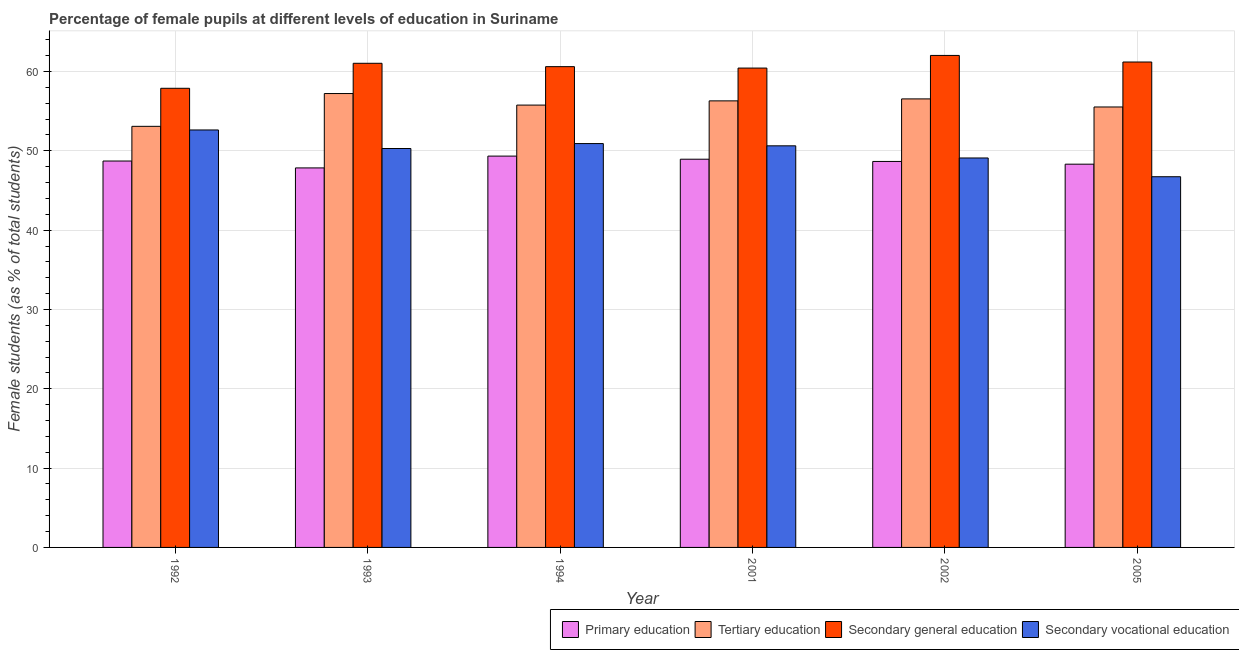Are the number of bars per tick equal to the number of legend labels?
Make the answer very short. Yes. Are the number of bars on each tick of the X-axis equal?
Your response must be concise. Yes. What is the label of the 1st group of bars from the left?
Give a very brief answer. 1992. In how many cases, is the number of bars for a given year not equal to the number of legend labels?
Offer a terse response. 0. What is the percentage of female students in secondary education in 1992?
Make the answer very short. 57.89. Across all years, what is the maximum percentage of female students in primary education?
Your response must be concise. 49.34. Across all years, what is the minimum percentage of female students in primary education?
Make the answer very short. 47.85. In which year was the percentage of female students in secondary vocational education maximum?
Provide a succinct answer. 1992. In which year was the percentage of female students in secondary education minimum?
Provide a succinct answer. 1992. What is the total percentage of female students in secondary vocational education in the graph?
Your answer should be very brief. 300.32. What is the difference between the percentage of female students in secondary vocational education in 1993 and that in 2005?
Provide a short and direct response. 3.56. What is the difference between the percentage of female students in secondary education in 1992 and the percentage of female students in primary education in 2005?
Give a very brief answer. -3.31. What is the average percentage of female students in tertiary education per year?
Your answer should be very brief. 55.75. In the year 2001, what is the difference between the percentage of female students in primary education and percentage of female students in secondary education?
Keep it short and to the point. 0. What is the ratio of the percentage of female students in secondary education in 1992 to that in 2005?
Provide a short and direct response. 0.95. Is the percentage of female students in secondary vocational education in 1993 less than that in 1994?
Your response must be concise. Yes. Is the difference between the percentage of female students in primary education in 1992 and 2002 greater than the difference between the percentage of female students in tertiary education in 1992 and 2002?
Offer a very short reply. No. What is the difference between the highest and the second highest percentage of female students in secondary vocational education?
Make the answer very short. 1.72. What is the difference between the highest and the lowest percentage of female students in primary education?
Ensure brevity in your answer.  1.49. In how many years, is the percentage of female students in tertiary education greater than the average percentage of female students in tertiary education taken over all years?
Ensure brevity in your answer.  4. What does the 3rd bar from the left in 2002 represents?
Your answer should be compact. Secondary general education. What does the 3rd bar from the right in 1993 represents?
Provide a short and direct response. Tertiary education. Is it the case that in every year, the sum of the percentage of female students in primary education and percentage of female students in tertiary education is greater than the percentage of female students in secondary education?
Keep it short and to the point. Yes. How many years are there in the graph?
Offer a very short reply. 6. Does the graph contain any zero values?
Make the answer very short. No. How many legend labels are there?
Your answer should be very brief. 4. What is the title of the graph?
Give a very brief answer. Percentage of female pupils at different levels of education in Suriname. What is the label or title of the Y-axis?
Offer a terse response. Female students (as % of total students). What is the Female students (as % of total students) of Primary education in 1992?
Make the answer very short. 48.72. What is the Female students (as % of total students) in Tertiary education in 1992?
Provide a succinct answer. 53.09. What is the Female students (as % of total students) in Secondary general education in 1992?
Your answer should be compact. 57.89. What is the Female students (as % of total students) of Secondary vocational education in 1992?
Give a very brief answer. 52.63. What is the Female students (as % of total students) in Primary education in 1993?
Keep it short and to the point. 47.85. What is the Female students (as % of total students) of Tertiary education in 1993?
Provide a short and direct response. 57.23. What is the Female students (as % of total students) in Secondary general education in 1993?
Make the answer very short. 61.04. What is the Female students (as % of total students) of Secondary vocational education in 1993?
Provide a succinct answer. 50.3. What is the Female students (as % of total students) in Primary education in 1994?
Make the answer very short. 49.34. What is the Female students (as % of total students) of Tertiary education in 1994?
Ensure brevity in your answer.  55.77. What is the Female students (as % of total students) in Secondary general education in 1994?
Your response must be concise. 60.62. What is the Female students (as % of total students) of Secondary vocational education in 1994?
Your answer should be very brief. 50.92. What is the Female students (as % of total students) in Primary education in 2001?
Your answer should be compact. 48.95. What is the Female students (as % of total students) in Tertiary education in 2001?
Your response must be concise. 56.3. What is the Female students (as % of total students) in Secondary general education in 2001?
Your answer should be very brief. 60.44. What is the Female students (as % of total students) of Secondary vocational education in 2001?
Give a very brief answer. 50.63. What is the Female students (as % of total students) in Primary education in 2002?
Ensure brevity in your answer.  48.67. What is the Female students (as % of total students) in Tertiary education in 2002?
Offer a very short reply. 56.55. What is the Female students (as % of total students) in Secondary general education in 2002?
Your response must be concise. 62.03. What is the Female students (as % of total students) of Secondary vocational education in 2002?
Provide a succinct answer. 49.1. What is the Female students (as % of total students) of Primary education in 2005?
Provide a succinct answer. 48.32. What is the Female students (as % of total students) in Tertiary education in 2005?
Make the answer very short. 55.53. What is the Female students (as % of total students) in Secondary general education in 2005?
Give a very brief answer. 61.2. What is the Female students (as % of total students) of Secondary vocational education in 2005?
Make the answer very short. 46.74. Across all years, what is the maximum Female students (as % of total students) in Primary education?
Your response must be concise. 49.34. Across all years, what is the maximum Female students (as % of total students) of Tertiary education?
Provide a short and direct response. 57.23. Across all years, what is the maximum Female students (as % of total students) of Secondary general education?
Provide a succinct answer. 62.03. Across all years, what is the maximum Female students (as % of total students) in Secondary vocational education?
Make the answer very short. 52.63. Across all years, what is the minimum Female students (as % of total students) in Primary education?
Keep it short and to the point. 47.85. Across all years, what is the minimum Female students (as % of total students) of Tertiary education?
Make the answer very short. 53.09. Across all years, what is the minimum Female students (as % of total students) of Secondary general education?
Your answer should be very brief. 57.89. Across all years, what is the minimum Female students (as % of total students) of Secondary vocational education?
Offer a very short reply. 46.74. What is the total Female students (as % of total students) in Primary education in the graph?
Your answer should be compact. 291.83. What is the total Female students (as % of total students) in Tertiary education in the graph?
Offer a terse response. 334.47. What is the total Female students (as % of total students) in Secondary general education in the graph?
Offer a terse response. 363.21. What is the total Female students (as % of total students) of Secondary vocational education in the graph?
Offer a terse response. 300.32. What is the difference between the Female students (as % of total students) in Primary education in 1992 and that in 1993?
Keep it short and to the point. 0.87. What is the difference between the Female students (as % of total students) of Tertiary education in 1992 and that in 1993?
Make the answer very short. -4.14. What is the difference between the Female students (as % of total students) in Secondary general education in 1992 and that in 1993?
Ensure brevity in your answer.  -3.15. What is the difference between the Female students (as % of total students) of Secondary vocational education in 1992 and that in 1993?
Your response must be concise. 2.34. What is the difference between the Female students (as % of total students) of Primary education in 1992 and that in 1994?
Provide a short and direct response. -0.62. What is the difference between the Female students (as % of total students) in Tertiary education in 1992 and that in 1994?
Your answer should be very brief. -2.68. What is the difference between the Female students (as % of total students) in Secondary general education in 1992 and that in 1994?
Keep it short and to the point. -2.73. What is the difference between the Female students (as % of total students) of Secondary vocational education in 1992 and that in 1994?
Give a very brief answer. 1.72. What is the difference between the Female students (as % of total students) in Primary education in 1992 and that in 2001?
Your answer should be compact. -0.23. What is the difference between the Female students (as % of total students) in Tertiary education in 1992 and that in 2001?
Give a very brief answer. -3.21. What is the difference between the Female students (as % of total students) in Secondary general education in 1992 and that in 2001?
Your response must be concise. -2.55. What is the difference between the Female students (as % of total students) of Secondary vocational education in 1992 and that in 2001?
Provide a short and direct response. 2. What is the difference between the Female students (as % of total students) of Primary education in 1992 and that in 2002?
Provide a short and direct response. 0.05. What is the difference between the Female students (as % of total students) in Tertiary education in 1992 and that in 2002?
Make the answer very short. -3.46. What is the difference between the Female students (as % of total students) in Secondary general education in 1992 and that in 2002?
Keep it short and to the point. -4.14. What is the difference between the Female students (as % of total students) in Secondary vocational education in 1992 and that in 2002?
Ensure brevity in your answer.  3.53. What is the difference between the Female students (as % of total students) of Primary education in 1992 and that in 2005?
Ensure brevity in your answer.  0.4. What is the difference between the Female students (as % of total students) in Tertiary education in 1992 and that in 2005?
Offer a terse response. -2.44. What is the difference between the Female students (as % of total students) of Secondary general education in 1992 and that in 2005?
Offer a very short reply. -3.31. What is the difference between the Female students (as % of total students) of Secondary vocational education in 1992 and that in 2005?
Keep it short and to the point. 5.9. What is the difference between the Female students (as % of total students) in Primary education in 1993 and that in 1994?
Provide a short and direct response. -1.49. What is the difference between the Female students (as % of total students) of Tertiary education in 1993 and that in 1994?
Offer a very short reply. 1.46. What is the difference between the Female students (as % of total students) of Secondary general education in 1993 and that in 1994?
Your response must be concise. 0.42. What is the difference between the Female students (as % of total students) of Secondary vocational education in 1993 and that in 1994?
Your answer should be very brief. -0.62. What is the difference between the Female students (as % of total students) in Primary education in 1993 and that in 2001?
Your answer should be very brief. -1.1. What is the difference between the Female students (as % of total students) in Tertiary education in 1993 and that in 2001?
Keep it short and to the point. 0.92. What is the difference between the Female students (as % of total students) in Secondary general education in 1993 and that in 2001?
Offer a very short reply. 0.6. What is the difference between the Female students (as % of total students) of Secondary vocational education in 1993 and that in 2001?
Provide a short and direct response. -0.34. What is the difference between the Female students (as % of total students) of Primary education in 1993 and that in 2002?
Keep it short and to the point. -0.82. What is the difference between the Female students (as % of total students) in Tertiary education in 1993 and that in 2002?
Make the answer very short. 0.68. What is the difference between the Female students (as % of total students) of Secondary general education in 1993 and that in 2002?
Your answer should be compact. -0.99. What is the difference between the Female students (as % of total students) of Secondary vocational education in 1993 and that in 2002?
Your answer should be very brief. 1.19. What is the difference between the Female students (as % of total students) of Primary education in 1993 and that in 2005?
Offer a terse response. -0.47. What is the difference between the Female students (as % of total students) in Tertiary education in 1993 and that in 2005?
Your response must be concise. 1.69. What is the difference between the Female students (as % of total students) of Secondary general education in 1993 and that in 2005?
Offer a terse response. -0.16. What is the difference between the Female students (as % of total students) of Secondary vocational education in 1993 and that in 2005?
Provide a succinct answer. 3.56. What is the difference between the Female students (as % of total students) of Primary education in 1994 and that in 2001?
Provide a succinct answer. 0.39. What is the difference between the Female students (as % of total students) in Tertiary education in 1994 and that in 2001?
Your answer should be compact. -0.53. What is the difference between the Female students (as % of total students) in Secondary general education in 1994 and that in 2001?
Offer a terse response. 0.18. What is the difference between the Female students (as % of total students) of Secondary vocational education in 1994 and that in 2001?
Give a very brief answer. 0.28. What is the difference between the Female students (as % of total students) of Primary education in 1994 and that in 2002?
Ensure brevity in your answer.  0.67. What is the difference between the Female students (as % of total students) in Tertiary education in 1994 and that in 2002?
Ensure brevity in your answer.  -0.78. What is the difference between the Female students (as % of total students) of Secondary general education in 1994 and that in 2002?
Ensure brevity in your answer.  -1.42. What is the difference between the Female students (as % of total students) of Secondary vocational education in 1994 and that in 2002?
Your response must be concise. 1.82. What is the difference between the Female students (as % of total students) of Primary education in 1994 and that in 2005?
Give a very brief answer. 1.02. What is the difference between the Female students (as % of total students) of Tertiary education in 1994 and that in 2005?
Keep it short and to the point. 0.24. What is the difference between the Female students (as % of total students) of Secondary general education in 1994 and that in 2005?
Provide a short and direct response. -0.58. What is the difference between the Female students (as % of total students) of Secondary vocational education in 1994 and that in 2005?
Ensure brevity in your answer.  4.18. What is the difference between the Female students (as % of total students) in Primary education in 2001 and that in 2002?
Your answer should be compact. 0.28. What is the difference between the Female students (as % of total students) of Tertiary education in 2001 and that in 2002?
Ensure brevity in your answer.  -0.25. What is the difference between the Female students (as % of total students) of Secondary general education in 2001 and that in 2002?
Ensure brevity in your answer.  -1.59. What is the difference between the Female students (as % of total students) of Secondary vocational education in 2001 and that in 2002?
Offer a terse response. 1.53. What is the difference between the Female students (as % of total students) in Primary education in 2001 and that in 2005?
Your answer should be very brief. 0.62. What is the difference between the Female students (as % of total students) of Tertiary education in 2001 and that in 2005?
Your response must be concise. 0.77. What is the difference between the Female students (as % of total students) of Secondary general education in 2001 and that in 2005?
Your answer should be very brief. -0.76. What is the difference between the Female students (as % of total students) of Secondary vocational education in 2001 and that in 2005?
Give a very brief answer. 3.9. What is the difference between the Female students (as % of total students) in Primary education in 2002 and that in 2005?
Offer a terse response. 0.34. What is the difference between the Female students (as % of total students) of Tertiary education in 2002 and that in 2005?
Offer a terse response. 1.02. What is the difference between the Female students (as % of total students) of Secondary general education in 2002 and that in 2005?
Make the answer very short. 0.83. What is the difference between the Female students (as % of total students) in Secondary vocational education in 2002 and that in 2005?
Offer a terse response. 2.37. What is the difference between the Female students (as % of total students) of Primary education in 1992 and the Female students (as % of total students) of Tertiary education in 1993?
Your response must be concise. -8.51. What is the difference between the Female students (as % of total students) in Primary education in 1992 and the Female students (as % of total students) in Secondary general education in 1993?
Offer a terse response. -12.32. What is the difference between the Female students (as % of total students) in Primary education in 1992 and the Female students (as % of total students) in Secondary vocational education in 1993?
Offer a very short reply. -1.58. What is the difference between the Female students (as % of total students) of Tertiary education in 1992 and the Female students (as % of total students) of Secondary general education in 1993?
Provide a succinct answer. -7.95. What is the difference between the Female students (as % of total students) in Tertiary education in 1992 and the Female students (as % of total students) in Secondary vocational education in 1993?
Your answer should be compact. 2.79. What is the difference between the Female students (as % of total students) of Secondary general education in 1992 and the Female students (as % of total students) of Secondary vocational education in 1993?
Provide a short and direct response. 7.59. What is the difference between the Female students (as % of total students) in Primary education in 1992 and the Female students (as % of total students) in Tertiary education in 1994?
Give a very brief answer. -7.05. What is the difference between the Female students (as % of total students) in Primary education in 1992 and the Female students (as % of total students) in Secondary general education in 1994?
Provide a succinct answer. -11.9. What is the difference between the Female students (as % of total students) in Primary education in 1992 and the Female students (as % of total students) in Secondary vocational education in 1994?
Your response must be concise. -2.2. What is the difference between the Female students (as % of total students) in Tertiary education in 1992 and the Female students (as % of total students) in Secondary general education in 1994?
Offer a very short reply. -7.53. What is the difference between the Female students (as % of total students) in Tertiary education in 1992 and the Female students (as % of total students) in Secondary vocational education in 1994?
Make the answer very short. 2.17. What is the difference between the Female students (as % of total students) of Secondary general education in 1992 and the Female students (as % of total students) of Secondary vocational education in 1994?
Offer a terse response. 6.97. What is the difference between the Female students (as % of total students) of Primary education in 1992 and the Female students (as % of total students) of Tertiary education in 2001?
Provide a succinct answer. -7.58. What is the difference between the Female students (as % of total students) in Primary education in 1992 and the Female students (as % of total students) in Secondary general education in 2001?
Your answer should be very brief. -11.72. What is the difference between the Female students (as % of total students) in Primary education in 1992 and the Female students (as % of total students) in Secondary vocational education in 2001?
Give a very brief answer. -1.92. What is the difference between the Female students (as % of total students) of Tertiary education in 1992 and the Female students (as % of total students) of Secondary general education in 2001?
Offer a terse response. -7.35. What is the difference between the Female students (as % of total students) in Tertiary education in 1992 and the Female students (as % of total students) in Secondary vocational education in 2001?
Offer a terse response. 2.46. What is the difference between the Female students (as % of total students) in Secondary general education in 1992 and the Female students (as % of total students) in Secondary vocational education in 2001?
Provide a short and direct response. 7.25. What is the difference between the Female students (as % of total students) of Primary education in 1992 and the Female students (as % of total students) of Tertiary education in 2002?
Your answer should be very brief. -7.83. What is the difference between the Female students (as % of total students) in Primary education in 1992 and the Female students (as % of total students) in Secondary general education in 2002?
Your answer should be compact. -13.31. What is the difference between the Female students (as % of total students) in Primary education in 1992 and the Female students (as % of total students) in Secondary vocational education in 2002?
Your answer should be compact. -0.38. What is the difference between the Female students (as % of total students) of Tertiary education in 1992 and the Female students (as % of total students) of Secondary general education in 2002?
Your answer should be very brief. -8.94. What is the difference between the Female students (as % of total students) in Tertiary education in 1992 and the Female students (as % of total students) in Secondary vocational education in 2002?
Give a very brief answer. 3.99. What is the difference between the Female students (as % of total students) in Secondary general education in 1992 and the Female students (as % of total students) in Secondary vocational education in 2002?
Your response must be concise. 8.79. What is the difference between the Female students (as % of total students) of Primary education in 1992 and the Female students (as % of total students) of Tertiary education in 2005?
Offer a very short reply. -6.82. What is the difference between the Female students (as % of total students) of Primary education in 1992 and the Female students (as % of total students) of Secondary general education in 2005?
Provide a short and direct response. -12.48. What is the difference between the Female students (as % of total students) of Primary education in 1992 and the Female students (as % of total students) of Secondary vocational education in 2005?
Provide a succinct answer. 1.98. What is the difference between the Female students (as % of total students) of Tertiary education in 1992 and the Female students (as % of total students) of Secondary general education in 2005?
Provide a succinct answer. -8.11. What is the difference between the Female students (as % of total students) of Tertiary education in 1992 and the Female students (as % of total students) of Secondary vocational education in 2005?
Your answer should be very brief. 6.35. What is the difference between the Female students (as % of total students) in Secondary general education in 1992 and the Female students (as % of total students) in Secondary vocational education in 2005?
Offer a terse response. 11.15. What is the difference between the Female students (as % of total students) of Primary education in 1993 and the Female students (as % of total students) of Tertiary education in 1994?
Offer a terse response. -7.92. What is the difference between the Female students (as % of total students) in Primary education in 1993 and the Female students (as % of total students) in Secondary general education in 1994?
Ensure brevity in your answer.  -12.77. What is the difference between the Female students (as % of total students) of Primary education in 1993 and the Female students (as % of total students) of Secondary vocational education in 1994?
Provide a succinct answer. -3.07. What is the difference between the Female students (as % of total students) of Tertiary education in 1993 and the Female students (as % of total students) of Secondary general education in 1994?
Your answer should be very brief. -3.39. What is the difference between the Female students (as % of total students) in Tertiary education in 1993 and the Female students (as % of total students) in Secondary vocational education in 1994?
Make the answer very short. 6.31. What is the difference between the Female students (as % of total students) of Secondary general education in 1993 and the Female students (as % of total students) of Secondary vocational education in 1994?
Make the answer very short. 10.12. What is the difference between the Female students (as % of total students) in Primary education in 1993 and the Female students (as % of total students) in Tertiary education in 2001?
Give a very brief answer. -8.45. What is the difference between the Female students (as % of total students) of Primary education in 1993 and the Female students (as % of total students) of Secondary general education in 2001?
Your answer should be very brief. -12.59. What is the difference between the Female students (as % of total students) in Primary education in 1993 and the Female students (as % of total students) in Secondary vocational education in 2001?
Your response must be concise. -2.79. What is the difference between the Female students (as % of total students) in Tertiary education in 1993 and the Female students (as % of total students) in Secondary general education in 2001?
Keep it short and to the point. -3.21. What is the difference between the Female students (as % of total students) of Tertiary education in 1993 and the Female students (as % of total students) of Secondary vocational education in 2001?
Your answer should be very brief. 6.59. What is the difference between the Female students (as % of total students) in Secondary general education in 1993 and the Female students (as % of total students) in Secondary vocational education in 2001?
Provide a succinct answer. 10.41. What is the difference between the Female students (as % of total students) in Primary education in 1993 and the Female students (as % of total students) in Tertiary education in 2002?
Ensure brevity in your answer.  -8.7. What is the difference between the Female students (as % of total students) in Primary education in 1993 and the Female students (as % of total students) in Secondary general education in 2002?
Provide a succinct answer. -14.18. What is the difference between the Female students (as % of total students) of Primary education in 1993 and the Female students (as % of total students) of Secondary vocational education in 2002?
Offer a very short reply. -1.25. What is the difference between the Female students (as % of total students) in Tertiary education in 1993 and the Female students (as % of total students) in Secondary general education in 2002?
Your answer should be very brief. -4.8. What is the difference between the Female students (as % of total students) in Tertiary education in 1993 and the Female students (as % of total students) in Secondary vocational education in 2002?
Your answer should be very brief. 8.12. What is the difference between the Female students (as % of total students) of Secondary general education in 1993 and the Female students (as % of total students) of Secondary vocational education in 2002?
Make the answer very short. 11.94. What is the difference between the Female students (as % of total students) of Primary education in 1993 and the Female students (as % of total students) of Tertiary education in 2005?
Provide a short and direct response. -7.68. What is the difference between the Female students (as % of total students) in Primary education in 1993 and the Female students (as % of total students) in Secondary general education in 2005?
Your response must be concise. -13.35. What is the difference between the Female students (as % of total students) in Primary education in 1993 and the Female students (as % of total students) in Secondary vocational education in 2005?
Provide a short and direct response. 1.11. What is the difference between the Female students (as % of total students) of Tertiary education in 1993 and the Female students (as % of total students) of Secondary general education in 2005?
Provide a short and direct response. -3.97. What is the difference between the Female students (as % of total students) of Tertiary education in 1993 and the Female students (as % of total students) of Secondary vocational education in 2005?
Offer a terse response. 10.49. What is the difference between the Female students (as % of total students) of Secondary general education in 1993 and the Female students (as % of total students) of Secondary vocational education in 2005?
Your answer should be compact. 14.3. What is the difference between the Female students (as % of total students) of Primary education in 1994 and the Female students (as % of total students) of Tertiary education in 2001?
Offer a very short reply. -6.96. What is the difference between the Female students (as % of total students) of Primary education in 1994 and the Female students (as % of total students) of Secondary general education in 2001?
Your answer should be compact. -11.1. What is the difference between the Female students (as % of total students) in Primary education in 1994 and the Female students (as % of total students) in Secondary vocational education in 2001?
Give a very brief answer. -1.3. What is the difference between the Female students (as % of total students) in Tertiary education in 1994 and the Female students (as % of total students) in Secondary general education in 2001?
Your answer should be compact. -4.67. What is the difference between the Female students (as % of total students) in Tertiary education in 1994 and the Female students (as % of total students) in Secondary vocational education in 2001?
Provide a succinct answer. 5.14. What is the difference between the Female students (as % of total students) in Secondary general education in 1994 and the Female students (as % of total students) in Secondary vocational education in 2001?
Offer a very short reply. 9.98. What is the difference between the Female students (as % of total students) in Primary education in 1994 and the Female students (as % of total students) in Tertiary education in 2002?
Your answer should be compact. -7.21. What is the difference between the Female students (as % of total students) in Primary education in 1994 and the Female students (as % of total students) in Secondary general education in 2002?
Offer a very short reply. -12.69. What is the difference between the Female students (as % of total students) of Primary education in 1994 and the Female students (as % of total students) of Secondary vocational education in 2002?
Give a very brief answer. 0.24. What is the difference between the Female students (as % of total students) of Tertiary education in 1994 and the Female students (as % of total students) of Secondary general education in 2002?
Provide a succinct answer. -6.26. What is the difference between the Female students (as % of total students) of Tertiary education in 1994 and the Female students (as % of total students) of Secondary vocational education in 2002?
Provide a short and direct response. 6.67. What is the difference between the Female students (as % of total students) in Secondary general education in 1994 and the Female students (as % of total students) in Secondary vocational education in 2002?
Your answer should be very brief. 11.51. What is the difference between the Female students (as % of total students) of Primary education in 1994 and the Female students (as % of total students) of Tertiary education in 2005?
Offer a terse response. -6.19. What is the difference between the Female students (as % of total students) of Primary education in 1994 and the Female students (as % of total students) of Secondary general education in 2005?
Keep it short and to the point. -11.86. What is the difference between the Female students (as % of total students) in Primary education in 1994 and the Female students (as % of total students) in Secondary vocational education in 2005?
Your response must be concise. 2.6. What is the difference between the Female students (as % of total students) in Tertiary education in 1994 and the Female students (as % of total students) in Secondary general education in 2005?
Provide a succinct answer. -5.43. What is the difference between the Female students (as % of total students) of Tertiary education in 1994 and the Female students (as % of total students) of Secondary vocational education in 2005?
Keep it short and to the point. 9.03. What is the difference between the Female students (as % of total students) in Secondary general education in 1994 and the Female students (as % of total students) in Secondary vocational education in 2005?
Provide a succinct answer. 13.88. What is the difference between the Female students (as % of total students) of Primary education in 2001 and the Female students (as % of total students) of Tertiary education in 2002?
Your answer should be very brief. -7.61. What is the difference between the Female students (as % of total students) in Primary education in 2001 and the Female students (as % of total students) in Secondary general education in 2002?
Make the answer very short. -13.09. What is the difference between the Female students (as % of total students) in Primary education in 2001 and the Female students (as % of total students) in Secondary vocational education in 2002?
Provide a succinct answer. -0.16. What is the difference between the Female students (as % of total students) of Tertiary education in 2001 and the Female students (as % of total students) of Secondary general education in 2002?
Ensure brevity in your answer.  -5.73. What is the difference between the Female students (as % of total students) in Tertiary education in 2001 and the Female students (as % of total students) in Secondary vocational education in 2002?
Offer a terse response. 7.2. What is the difference between the Female students (as % of total students) of Secondary general education in 2001 and the Female students (as % of total students) of Secondary vocational education in 2002?
Your response must be concise. 11.34. What is the difference between the Female students (as % of total students) of Primary education in 2001 and the Female students (as % of total students) of Tertiary education in 2005?
Make the answer very short. -6.59. What is the difference between the Female students (as % of total students) of Primary education in 2001 and the Female students (as % of total students) of Secondary general education in 2005?
Ensure brevity in your answer.  -12.26. What is the difference between the Female students (as % of total students) of Primary education in 2001 and the Female students (as % of total students) of Secondary vocational education in 2005?
Your response must be concise. 2.21. What is the difference between the Female students (as % of total students) in Tertiary education in 2001 and the Female students (as % of total students) in Secondary general education in 2005?
Make the answer very short. -4.9. What is the difference between the Female students (as % of total students) in Tertiary education in 2001 and the Female students (as % of total students) in Secondary vocational education in 2005?
Offer a very short reply. 9.56. What is the difference between the Female students (as % of total students) in Secondary general education in 2001 and the Female students (as % of total students) in Secondary vocational education in 2005?
Provide a short and direct response. 13.7. What is the difference between the Female students (as % of total students) in Primary education in 2002 and the Female students (as % of total students) in Tertiary education in 2005?
Keep it short and to the point. -6.87. What is the difference between the Female students (as % of total students) in Primary education in 2002 and the Female students (as % of total students) in Secondary general education in 2005?
Make the answer very short. -12.54. What is the difference between the Female students (as % of total students) of Primary education in 2002 and the Female students (as % of total students) of Secondary vocational education in 2005?
Make the answer very short. 1.93. What is the difference between the Female students (as % of total students) of Tertiary education in 2002 and the Female students (as % of total students) of Secondary general education in 2005?
Your answer should be compact. -4.65. What is the difference between the Female students (as % of total students) of Tertiary education in 2002 and the Female students (as % of total students) of Secondary vocational education in 2005?
Your response must be concise. 9.81. What is the difference between the Female students (as % of total students) in Secondary general education in 2002 and the Female students (as % of total students) in Secondary vocational education in 2005?
Offer a terse response. 15.29. What is the average Female students (as % of total students) in Primary education per year?
Ensure brevity in your answer.  48.64. What is the average Female students (as % of total students) of Tertiary education per year?
Provide a short and direct response. 55.75. What is the average Female students (as % of total students) of Secondary general education per year?
Provide a short and direct response. 60.54. What is the average Female students (as % of total students) of Secondary vocational education per year?
Ensure brevity in your answer.  50.05. In the year 1992, what is the difference between the Female students (as % of total students) of Primary education and Female students (as % of total students) of Tertiary education?
Ensure brevity in your answer.  -4.37. In the year 1992, what is the difference between the Female students (as % of total students) of Primary education and Female students (as % of total students) of Secondary general education?
Provide a succinct answer. -9.17. In the year 1992, what is the difference between the Female students (as % of total students) of Primary education and Female students (as % of total students) of Secondary vocational education?
Give a very brief answer. -3.92. In the year 1992, what is the difference between the Female students (as % of total students) of Tertiary education and Female students (as % of total students) of Secondary general education?
Make the answer very short. -4.8. In the year 1992, what is the difference between the Female students (as % of total students) in Tertiary education and Female students (as % of total students) in Secondary vocational education?
Offer a very short reply. 0.46. In the year 1992, what is the difference between the Female students (as % of total students) of Secondary general education and Female students (as % of total students) of Secondary vocational education?
Provide a short and direct response. 5.25. In the year 1993, what is the difference between the Female students (as % of total students) in Primary education and Female students (as % of total students) in Tertiary education?
Ensure brevity in your answer.  -9.38. In the year 1993, what is the difference between the Female students (as % of total students) of Primary education and Female students (as % of total students) of Secondary general education?
Your response must be concise. -13.19. In the year 1993, what is the difference between the Female students (as % of total students) in Primary education and Female students (as % of total students) in Secondary vocational education?
Provide a succinct answer. -2.45. In the year 1993, what is the difference between the Female students (as % of total students) in Tertiary education and Female students (as % of total students) in Secondary general education?
Offer a terse response. -3.81. In the year 1993, what is the difference between the Female students (as % of total students) of Tertiary education and Female students (as % of total students) of Secondary vocational education?
Your response must be concise. 6.93. In the year 1993, what is the difference between the Female students (as % of total students) of Secondary general education and Female students (as % of total students) of Secondary vocational education?
Give a very brief answer. 10.75. In the year 1994, what is the difference between the Female students (as % of total students) in Primary education and Female students (as % of total students) in Tertiary education?
Your response must be concise. -6.43. In the year 1994, what is the difference between the Female students (as % of total students) in Primary education and Female students (as % of total students) in Secondary general education?
Offer a terse response. -11.28. In the year 1994, what is the difference between the Female students (as % of total students) of Primary education and Female students (as % of total students) of Secondary vocational education?
Give a very brief answer. -1.58. In the year 1994, what is the difference between the Female students (as % of total students) of Tertiary education and Female students (as % of total students) of Secondary general education?
Provide a short and direct response. -4.85. In the year 1994, what is the difference between the Female students (as % of total students) in Tertiary education and Female students (as % of total students) in Secondary vocational education?
Your response must be concise. 4.85. In the year 1994, what is the difference between the Female students (as % of total students) of Secondary general education and Female students (as % of total students) of Secondary vocational education?
Your answer should be compact. 9.7. In the year 2001, what is the difference between the Female students (as % of total students) in Primary education and Female students (as % of total students) in Tertiary education?
Make the answer very short. -7.36. In the year 2001, what is the difference between the Female students (as % of total students) in Primary education and Female students (as % of total students) in Secondary general education?
Ensure brevity in your answer.  -11.49. In the year 2001, what is the difference between the Female students (as % of total students) of Primary education and Female students (as % of total students) of Secondary vocational education?
Provide a succinct answer. -1.69. In the year 2001, what is the difference between the Female students (as % of total students) of Tertiary education and Female students (as % of total students) of Secondary general education?
Provide a succinct answer. -4.14. In the year 2001, what is the difference between the Female students (as % of total students) of Tertiary education and Female students (as % of total students) of Secondary vocational education?
Offer a very short reply. 5.67. In the year 2001, what is the difference between the Female students (as % of total students) of Secondary general education and Female students (as % of total students) of Secondary vocational education?
Make the answer very short. 9.8. In the year 2002, what is the difference between the Female students (as % of total students) in Primary education and Female students (as % of total students) in Tertiary education?
Offer a terse response. -7.89. In the year 2002, what is the difference between the Female students (as % of total students) in Primary education and Female students (as % of total students) in Secondary general education?
Offer a very short reply. -13.37. In the year 2002, what is the difference between the Female students (as % of total students) of Primary education and Female students (as % of total students) of Secondary vocational education?
Keep it short and to the point. -0.44. In the year 2002, what is the difference between the Female students (as % of total students) of Tertiary education and Female students (as % of total students) of Secondary general education?
Offer a terse response. -5.48. In the year 2002, what is the difference between the Female students (as % of total students) in Tertiary education and Female students (as % of total students) in Secondary vocational education?
Give a very brief answer. 7.45. In the year 2002, what is the difference between the Female students (as % of total students) of Secondary general education and Female students (as % of total students) of Secondary vocational education?
Provide a short and direct response. 12.93. In the year 2005, what is the difference between the Female students (as % of total students) of Primary education and Female students (as % of total students) of Tertiary education?
Give a very brief answer. -7.21. In the year 2005, what is the difference between the Female students (as % of total students) in Primary education and Female students (as % of total students) in Secondary general education?
Provide a short and direct response. -12.88. In the year 2005, what is the difference between the Female students (as % of total students) in Primary education and Female students (as % of total students) in Secondary vocational education?
Give a very brief answer. 1.58. In the year 2005, what is the difference between the Female students (as % of total students) of Tertiary education and Female students (as % of total students) of Secondary general education?
Keep it short and to the point. -5.67. In the year 2005, what is the difference between the Female students (as % of total students) in Tertiary education and Female students (as % of total students) in Secondary vocational education?
Keep it short and to the point. 8.8. In the year 2005, what is the difference between the Female students (as % of total students) of Secondary general education and Female students (as % of total students) of Secondary vocational education?
Ensure brevity in your answer.  14.46. What is the ratio of the Female students (as % of total students) in Primary education in 1992 to that in 1993?
Make the answer very short. 1.02. What is the ratio of the Female students (as % of total students) in Tertiary education in 1992 to that in 1993?
Provide a succinct answer. 0.93. What is the ratio of the Female students (as % of total students) of Secondary general education in 1992 to that in 1993?
Offer a terse response. 0.95. What is the ratio of the Female students (as % of total students) of Secondary vocational education in 1992 to that in 1993?
Your response must be concise. 1.05. What is the ratio of the Female students (as % of total students) of Primary education in 1992 to that in 1994?
Offer a terse response. 0.99. What is the ratio of the Female students (as % of total students) in Tertiary education in 1992 to that in 1994?
Your response must be concise. 0.95. What is the ratio of the Female students (as % of total students) in Secondary general education in 1992 to that in 1994?
Give a very brief answer. 0.95. What is the ratio of the Female students (as % of total students) of Secondary vocational education in 1992 to that in 1994?
Your answer should be compact. 1.03. What is the ratio of the Female students (as % of total students) in Primary education in 1992 to that in 2001?
Provide a succinct answer. 1. What is the ratio of the Female students (as % of total students) of Tertiary education in 1992 to that in 2001?
Provide a short and direct response. 0.94. What is the ratio of the Female students (as % of total students) in Secondary general education in 1992 to that in 2001?
Provide a short and direct response. 0.96. What is the ratio of the Female students (as % of total students) in Secondary vocational education in 1992 to that in 2001?
Give a very brief answer. 1.04. What is the ratio of the Female students (as % of total students) in Primary education in 1992 to that in 2002?
Offer a very short reply. 1. What is the ratio of the Female students (as % of total students) in Tertiary education in 1992 to that in 2002?
Give a very brief answer. 0.94. What is the ratio of the Female students (as % of total students) in Secondary general education in 1992 to that in 2002?
Keep it short and to the point. 0.93. What is the ratio of the Female students (as % of total students) of Secondary vocational education in 1992 to that in 2002?
Your answer should be compact. 1.07. What is the ratio of the Female students (as % of total students) in Primary education in 1992 to that in 2005?
Ensure brevity in your answer.  1.01. What is the ratio of the Female students (as % of total students) of Tertiary education in 1992 to that in 2005?
Offer a terse response. 0.96. What is the ratio of the Female students (as % of total students) of Secondary general education in 1992 to that in 2005?
Keep it short and to the point. 0.95. What is the ratio of the Female students (as % of total students) of Secondary vocational education in 1992 to that in 2005?
Your answer should be very brief. 1.13. What is the ratio of the Female students (as % of total students) in Primary education in 1993 to that in 1994?
Provide a succinct answer. 0.97. What is the ratio of the Female students (as % of total students) in Tertiary education in 1993 to that in 1994?
Your answer should be compact. 1.03. What is the ratio of the Female students (as % of total students) of Secondary general education in 1993 to that in 1994?
Give a very brief answer. 1.01. What is the ratio of the Female students (as % of total students) of Primary education in 1993 to that in 2001?
Provide a succinct answer. 0.98. What is the ratio of the Female students (as % of total students) in Tertiary education in 1993 to that in 2001?
Your answer should be very brief. 1.02. What is the ratio of the Female students (as % of total students) in Secondary general education in 1993 to that in 2001?
Keep it short and to the point. 1.01. What is the ratio of the Female students (as % of total students) of Primary education in 1993 to that in 2002?
Keep it short and to the point. 0.98. What is the ratio of the Female students (as % of total students) in Tertiary education in 1993 to that in 2002?
Provide a succinct answer. 1.01. What is the ratio of the Female students (as % of total students) in Secondary vocational education in 1993 to that in 2002?
Your response must be concise. 1.02. What is the ratio of the Female students (as % of total students) of Primary education in 1993 to that in 2005?
Ensure brevity in your answer.  0.99. What is the ratio of the Female students (as % of total students) in Tertiary education in 1993 to that in 2005?
Offer a terse response. 1.03. What is the ratio of the Female students (as % of total students) in Secondary vocational education in 1993 to that in 2005?
Keep it short and to the point. 1.08. What is the ratio of the Female students (as % of total students) of Tertiary education in 1994 to that in 2001?
Offer a very short reply. 0.99. What is the ratio of the Female students (as % of total students) of Secondary general education in 1994 to that in 2001?
Offer a very short reply. 1. What is the ratio of the Female students (as % of total students) in Secondary vocational education in 1994 to that in 2001?
Your answer should be compact. 1.01. What is the ratio of the Female students (as % of total students) in Primary education in 1994 to that in 2002?
Provide a succinct answer. 1.01. What is the ratio of the Female students (as % of total students) of Tertiary education in 1994 to that in 2002?
Your answer should be compact. 0.99. What is the ratio of the Female students (as % of total students) in Secondary general education in 1994 to that in 2002?
Your response must be concise. 0.98. What is the ratio of the Female students (as % of total students) in Secondary vocational education in 1994 to that in 2002?
Provide a succinct answer. 1.04. What is the ratio of the Female students (as % of total students) of Primary education in 1994 to that in 2005?
Your answer should be very brief. 1.02. What is the ratio of the Female students (as % of total students) in Secondary vocational education in 1994 to that in 2005?
Give a very brief answer. 1.09. What is the ratio of the Female students (as % of total students) in Tertiary education in 2001 to that in 2002?
Ensure brevity in your answer.  1. What is the ratio of the Female students (as % of total students) of Secondary general education in 2001 to that in 2002?
Your answer should be very brief. 0.97. What is the ratio of the Female students (as % of total students) of Secondary vocational education in 2001 to that in 2002?
Give a very brief answer. 1.03. What is the ratio of the Female students (as % of total students) of Primary education in 2001 to that in 2005?
Offer a very short reply. 1.01. What is the ratio of the Female students (as % of total students) of Tertiary education in 2001 to that in 2005?
Your answer should be very brief. 1.01. What is the ratio of the Female students (as % of total students) in Secondary general education in 2001 to that in 2005?
Ensure brevity in your answer.  0.99. What is the ratio of the Female students (as % of total students) in Secondary vocational education in 2001 to that in 2005?
Your answer should be very brief. 1.08. What is the ratio of the Female students (as % of total students) of Primary education in 2002 to that in 2005?
Your answer should be compact. 1.01. What is the ratio of the Female students (as % of total students) in Tertiary education in 2002 to that in 2005?
Offer a very short reply. 1.02. What is the ratio of the Female students (as % of total students) of Secondary general education in 2002 to that in 2005?
Ensure brevity in your answer.  1.01. What is the ratio of the Female students (as % of total students) of Secondary vocational education in 2002 to that in 2005?
Offer a very short reply. 1.05. What is the difference between the highest and the second highest Female students (as % of total students) of Primary education?
Your answer should be very brief. 0.39. What is the difference between the highest and the second highest Female students (as % of total students) of Tertiary education?
Make the answer very short. 0.68. What is the difference between the highest and the second highest Female students (as % of total students) of Secondary general education?
Give a very brief answer. 0.83. What is the difference between the highest and the second highest Female students (as % of total students) in Secondary vocational education?
Provide a short and direct response. 1.72. What is the difference between the highest and the lowest Female students (as % of total students) in Primary education?
Make the answer very short. 1.49. What is the difference between the highest and the lowest Female students (as % of total students) of Tertiary education?
Ensure brevity in your answer.  4.14. What is the difference between the highest and the lowest Female students (as % of total students) of Secondary general education?
Offer a very short reply. 4.14. What is the difference between the highest and the lowest Female students (as % of total students) of Secondary vocational education?
Keep it short and to the point. 5.9. 